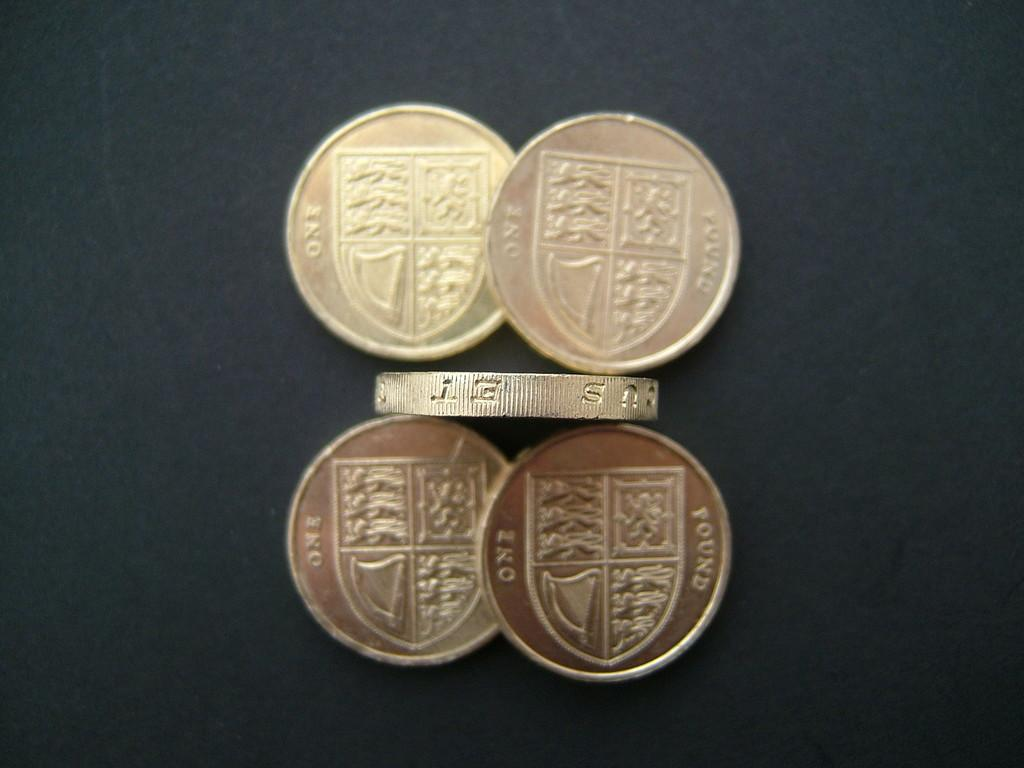<image>
Relay a brief, clear account of the picture shown. Several British coins worth One Pound sit on a black table 